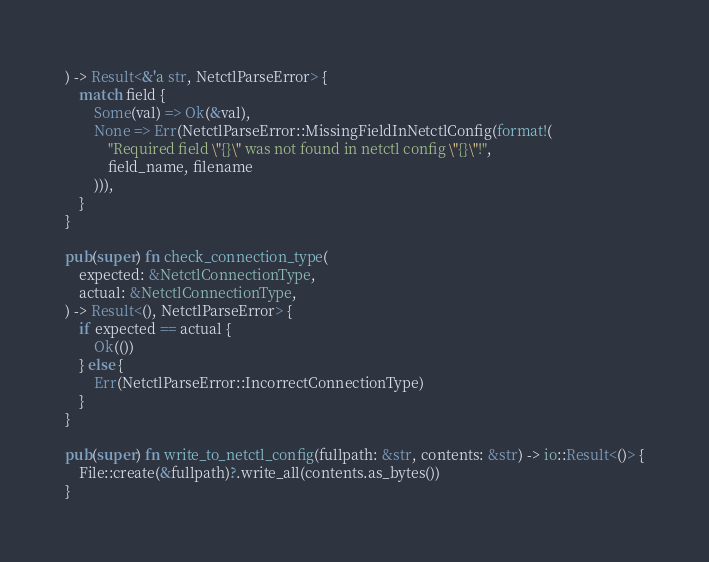<code> <loc_0><loc_0><loc_500><loc_500><_Rust_>) -> Result<&'a str, NetctlParseError> {
    match field {
        Some(val) => Ok(&val),
        None => Err(NetctlParseError::MissingFieldInNetctlConfig(format!(
            "Required field \"{}\" was not found in netctl config \"{}\"!",
            field_name, filename
        ))),
    }
}

pub(super) fn check_connection_type(
    expected: &NetctlConnectionType,
    actual: &NetctlConnectionType,
) -> Result<(), NetctlParseError> {
    if expected == actual {
        Ok(())
    } else {
        Err(NetctlParseError::IncorrectConnectionType)
    }
}

pub(super) fn write_to_netctl_config(fullpath: &str, contents: &str) -> io::Result<()> {
    File::create(&fullpath)?.write_all(contents.as_bytes())
}
</code> 